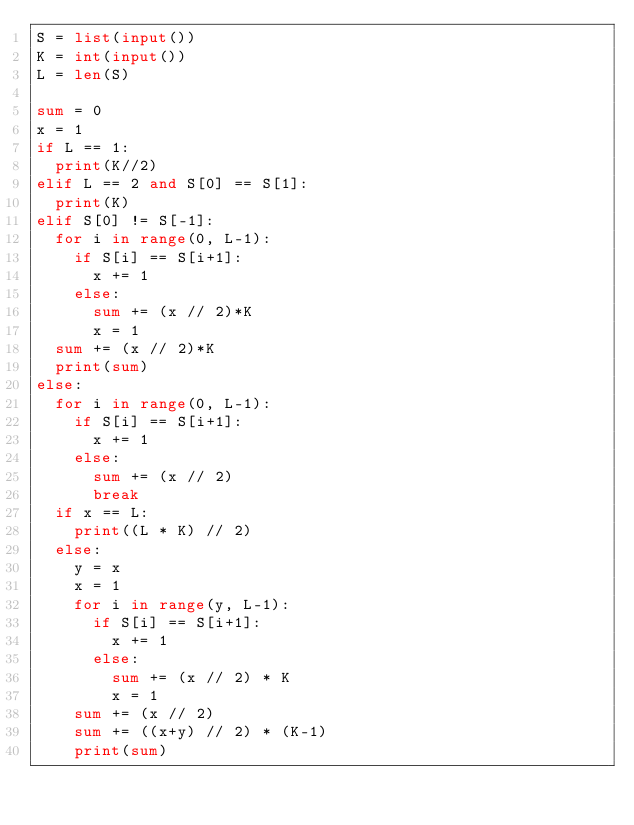Convert code to text. <code><loc_0><loc_0><loc_500><loc_500><_Python_>S = list(input())
K = int(input())
L = len(S)

sum = 0
x = 1
if L == 1:
  print(K//2)
elif L == 2 and S[0] == S[1]:
  print(K)
elif S[0] != S[-1]:
  for i in range(0, L-1):
    if S[i] == S[i+1]:
      x += 1
    else:
      sum += (x // 2)*K
      x = 1
  sum += (x // 2)*K
  print(sum)
else:
  for i in range(0, L-1):
    if S[i] == S[i+1]:
      x += 1
    else:
      sum += (x // 2)
      break
  if x == L:
    print((L * K) // 2)
  else:
    y = x
    x = 1
    for i in range(y, L-1):
      if S[i] == S[i+1]:
        x += 1
      else:
        sum += (x // 2) * K
        x = 1
    sum += (x // 2)
    sum += ((x+y) // 2) * (K-1)
    print(sum)</code> 